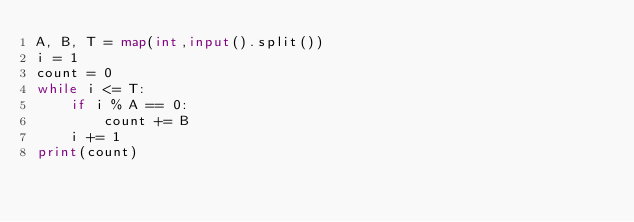Convert code to text. <code><loc_0><loc_0><loc_500><loc_500><_Python_>A, B, T = map(int,input().split())
i = 1
count = 0
while i <= T:
    if i % A == 0:
        count += B
    i += 1
print(count)
</code> 